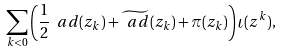Convert formula to latex. <formula><loc_0><loc_0><loc_500><loc_500>\sum _ { k < 0 } \left ( \frac { 1 } { 2 } \ a d ( z _ { k } ) + \widetilde { \ a d } ( z _ { k } ) + \pi ( z _ { k } ) \right ) \iota ( z ^ { k } ) ,</formula> 